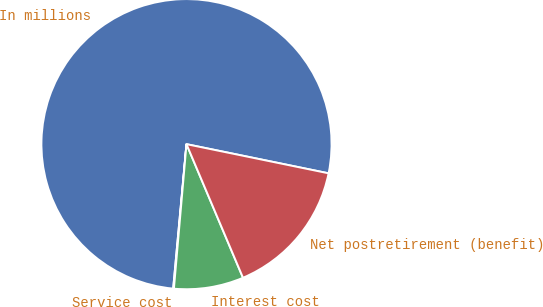Convert chart. <chart><loc_0><loc_0><loc_500><loc_500><pie_chart><fcel>In millions<fcel>Service cost<fcel>Interest cost<fcel>Net postretirement (benefit)<nl><fcel>76.76%<fcel>0.08%<fcel>7.75%<fcel>15.41%<nl></chart> 